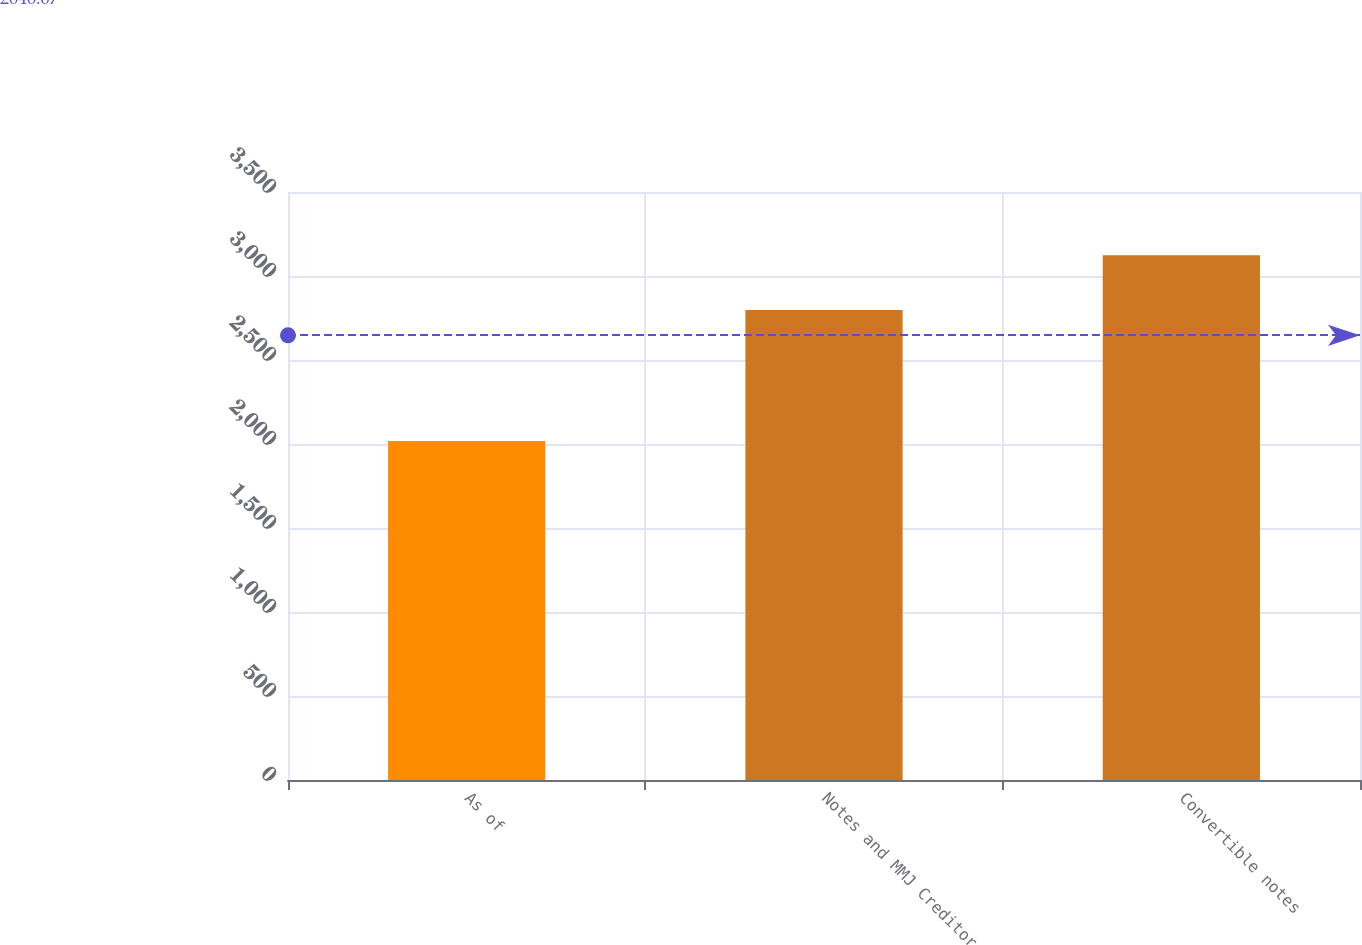<chart> <loc_0><loc_0><loc_500><loc_500><bar_chart><fcel>As of<fcel>Notes and MMJ Creditor<fcel>Convertible notes<nl><fcel>2018<fcel>2798<fcel>3124<nl></chart> 